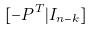<formula> <loc_0><loc_0><loc_500><loc_500>[ - P ^ { T } | I _ { n - k } ]</formula> 